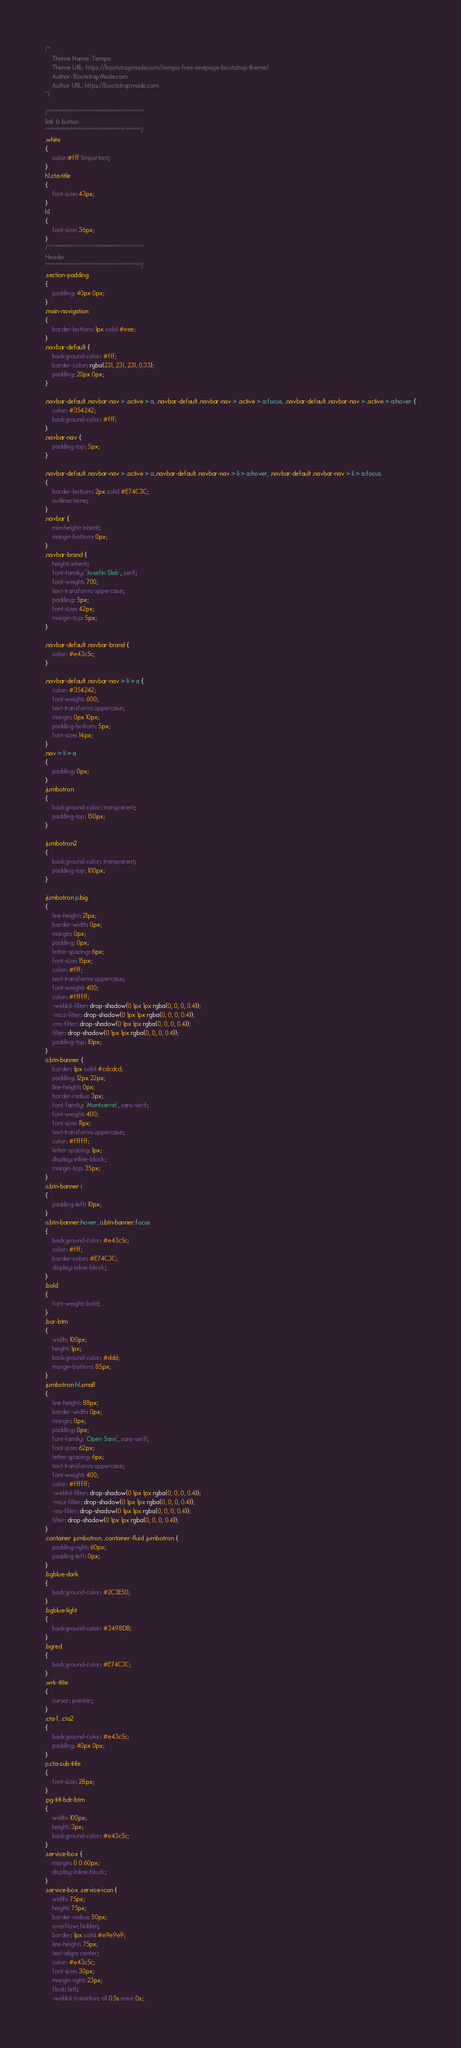<code> <loc_0><loc_0><loc_500><loc_500><_CSS_>/*
    Theme Name: Tempo
    Theme URL: https://bootstrapmade.com/tempo-free-onepage-bootstrap-theme/
    Author: BootstrapMade.com
    Author URL: https://bootstrapmade.com
*/

/**************************************
link & button
**************************************/
.white
{
	color:#fff !important;
}
h1.cta-title
{
	font-size: 43px;
}
h1
{
	font-size: 36px;
}
/**************************************
Header
**************************************/
.section-padding
{
	padding: 40px 0px;
}
.main-navigation
{
    border-bottom: 1px solid #eee;
}
.navbar-default {
    background-color: #fff;
    border-color: rgba(231, 231, 231, 0.33);
    padding: 20px 0px;
}

.navbar-default .navbar-nav > .active > a, .navbar-default .navbar-nav > .active > a:focus, .navbar-default .navbar-nav > .active > a:hover {
    color: #354242;
    background-color: #fff;
}
.navbar-nav {
    padding-top: 5px;
}

.navbar-default .navbar-nav > .active > a,.navbar-default .navbar-nav > li > a:hover, .navbar-default .navbar-nav > li > a:focus
{
	border-bottom: 2px solid #E74C3C;
    outline: none;
}
.navbar {
	min-height: inherit;
	margin-bottom: 0px;
}
.navbar-brand {
	height: inherit;
	font-family: 'Josefin Slab', serif;
	font-weight: 700;
	text-transform: uppercase;
	padding: 5px;
    font-size: 42px;
    margin-top: 5px;
}

.navbar-default .navbar-brand {
    color: #e43c5c;
}

.navbar-default .navbar-nav > li > a {
	color: #354242;
	font-weight: 600;
	text-transform: uppercase;
	margin: 0px 10px;
	padding-bottom: 5px;
	font-size: 14px;
}
.nav > li > a
{
	padding: 0px;
}
.jumbotron
{
    background-color: transparent;
    padding-top: 150px;
}

.jumbotron2
{
    background-color: transparent;
    padding-top: 100px;
}

.jumbotron p.big
{
    line-height: 21px;
    border-width: 0px;
    margin: 0px;
    padding: 0px;
    letter-spacing: 6px;
    font-size: 15px;
    color: #fff;
    text-transform: uppercase;
    font-weight: 400;
    color: #ffffff;
    -webkit-filter: drop-shadow(0 1px 1px rgba(0, 0, 0, 0.4));
    -moz-filter: drop-shadow(0 1px 1px rgba(0, 0, 0, 0.4));
    -ms-filter: drop-shadow(0 1px 1px rgba(0, 0, 0, 0.4));
    filter: drop-shadow(0 1px 1px rgba(0, 0, 0, 0.4));
    padding-top: 10px;
}
a.btn-banner {
    border: 1px solid #cdcdcd;
    padding: 12px 22px;
    line-height: 0px;
    border-radius: 3px;
    font-family: 'Montserrat', sans-serif;
    font-weight: 400;
    font-size: 11px;
    text-transform: uppercase;
    color: #ffffff;
    letter-spacing: 1px;
    display: inline-block;
    margin-top: 35px;
}
a.btn-banner i
{
    padding-left: 10px;
}
a.btn-banner:hover, a.btn-banner:focus
{
    background-color: #e43c5c;
    color: #fff;
    border-color: #E74C3C;
    display: inline-block;
}
.bold
{
    font-weight: bold;
}
.bor-btm
{
    width: 100px;
    height: 1px;
    background-color: #ddd;
    margin-bottom: 85px;
}
.jumbotron h1.small
{
    line-height: 88px;
    border-width: 0px;
    margin: 0px;
    padding: 0px;
    font-family: 'Open Sans', sans-serif;
    font-size: 62px;
    letter-spacing: 6px;
    text-transform: uppercase;
    font-weight: 400;
    color: #ffffff;
    -webkit-filter: drop-shadow(0 1px 1px rgba(0, 0, 0, 0.4));
    -moz-filter: drop-shadow(0 1px 1px rgba(0, 0, 0, 0.4));
    -ms-filter: drop-shadow(0 1px 1px rgba(0, 0, 0, 0.4));
    filter: drop-shadow(0 1px 1px rgba(0, 0, 0, 0.4));
}
.container .jumbotron, .container-fluid .jumbotron {
    padding-right: 60px;
    padding-left: 0px;
}
.bgblue-dark
{
    background-color: #2C3E50;
}
.bgblue-light
{
    background-color: #3498DB;
}
.bgred
{
    background-color: #E74C3C;
}
.wrk-title
{
    cursor: pointer;
}
.cta-1, .cta2
{
	background-color: #e43c5c;
	padding: 40px 0px;
}
p.cta-sub-title
{
	font-size: 28px;
}
.pg-titl-bdr-btm
{
	width: 100px;
	height: 3px;
	background-color: #e43c5c;
}
.service-box {
    margin: 0 0 60px;
    display: inline-block;
}
.service-box .service-icon {
    width: 75px;
    height: 75px;
    border-radius: 50px;
    overflow: hidden;
    border: 1px solid #e9e9e9;
    line-height: 75px;
    text-align: center;
    color: #e43c5c;
    font-size: 30px;
    margin-right: 23px;
    float: left;
    -webkit-transition: all 0.5s ease 0s;</code> 